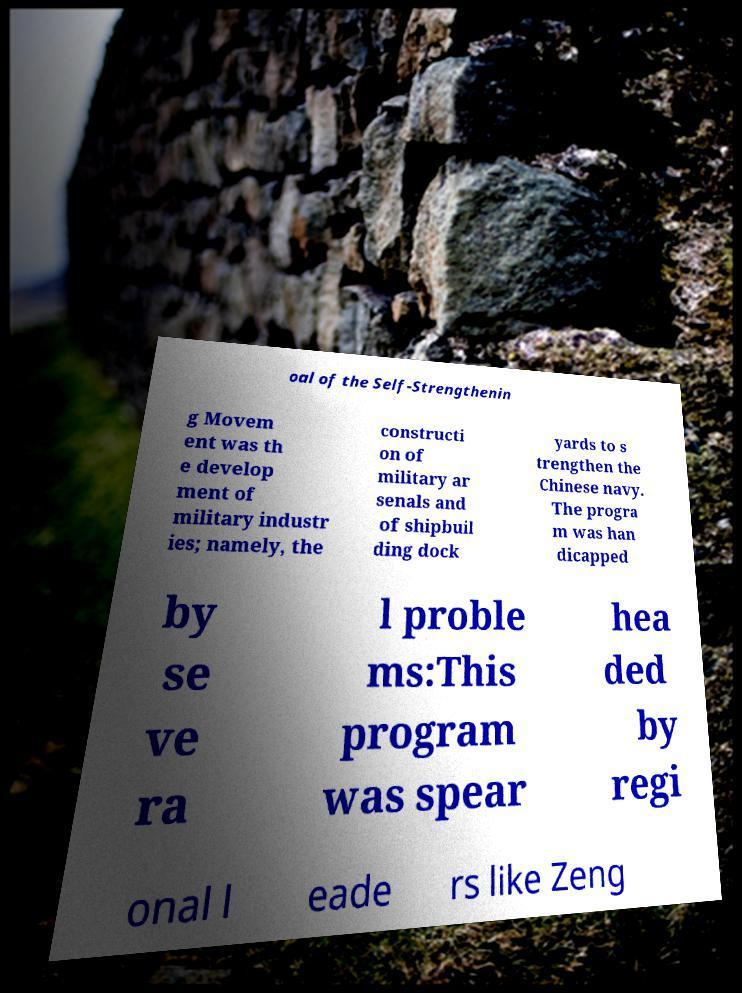Please identify and transcribe the text found in this image. oal of the Self-Strengthenin g Movem ent was th e develop ment of military industr ies; namely, the constructi on of military ar senals and of shipbuil ding dock yards to s trengthen the Chinese navy. The progra m was han dicapped by se ve ra l proble ms:This program was spear hea ded by regi onal l eade rs like Zeng 